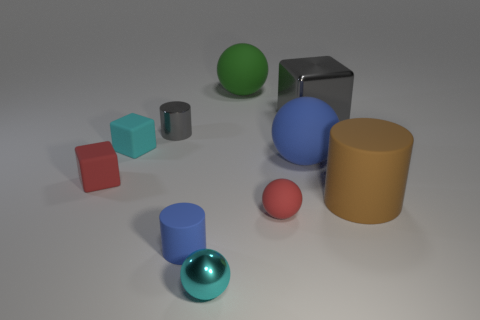Is the number of small red rubber things that are on the right side of the small cyan metal sphere greater than the number of tiny red rubber blocks that are right of the big green matte object?
Ensure brevity in your answer.  Yes. There is a object that is the same color as the small shiny cylinder; what is its size?
Your answer should be very brief. Large. The large block has what color?
Give a very brief answer. Gray. What color is the shiny object that is both right of the small gray shiny thing and behind the red ball?
Your answer should be compact. Gray. There is a rubber cylinder left of the gray shiny object right of the tiny cyan sphere in front of the metal cylinder; what color is it?
Give a very brief answer. Blue. What is the color of the matte sphere that is the same size as the red block?
Offer a terse response. Red. What shape is the gray metallic thing that is on the right side of the sphere behind the gray metallic object that is left of the gray block?
Make the answer very short. Cube. There is a object that is the same color as the tiny rubber ball; what shape is it?
Your answer should be compact. Cube. What number of objects are small cylinders or red objects that are in front of the big rubber cylinder?
Offer a terse response. 3. Do the blue object in front of the red matte block and the red block have the same size?
Offer a very short reply. Yes. 